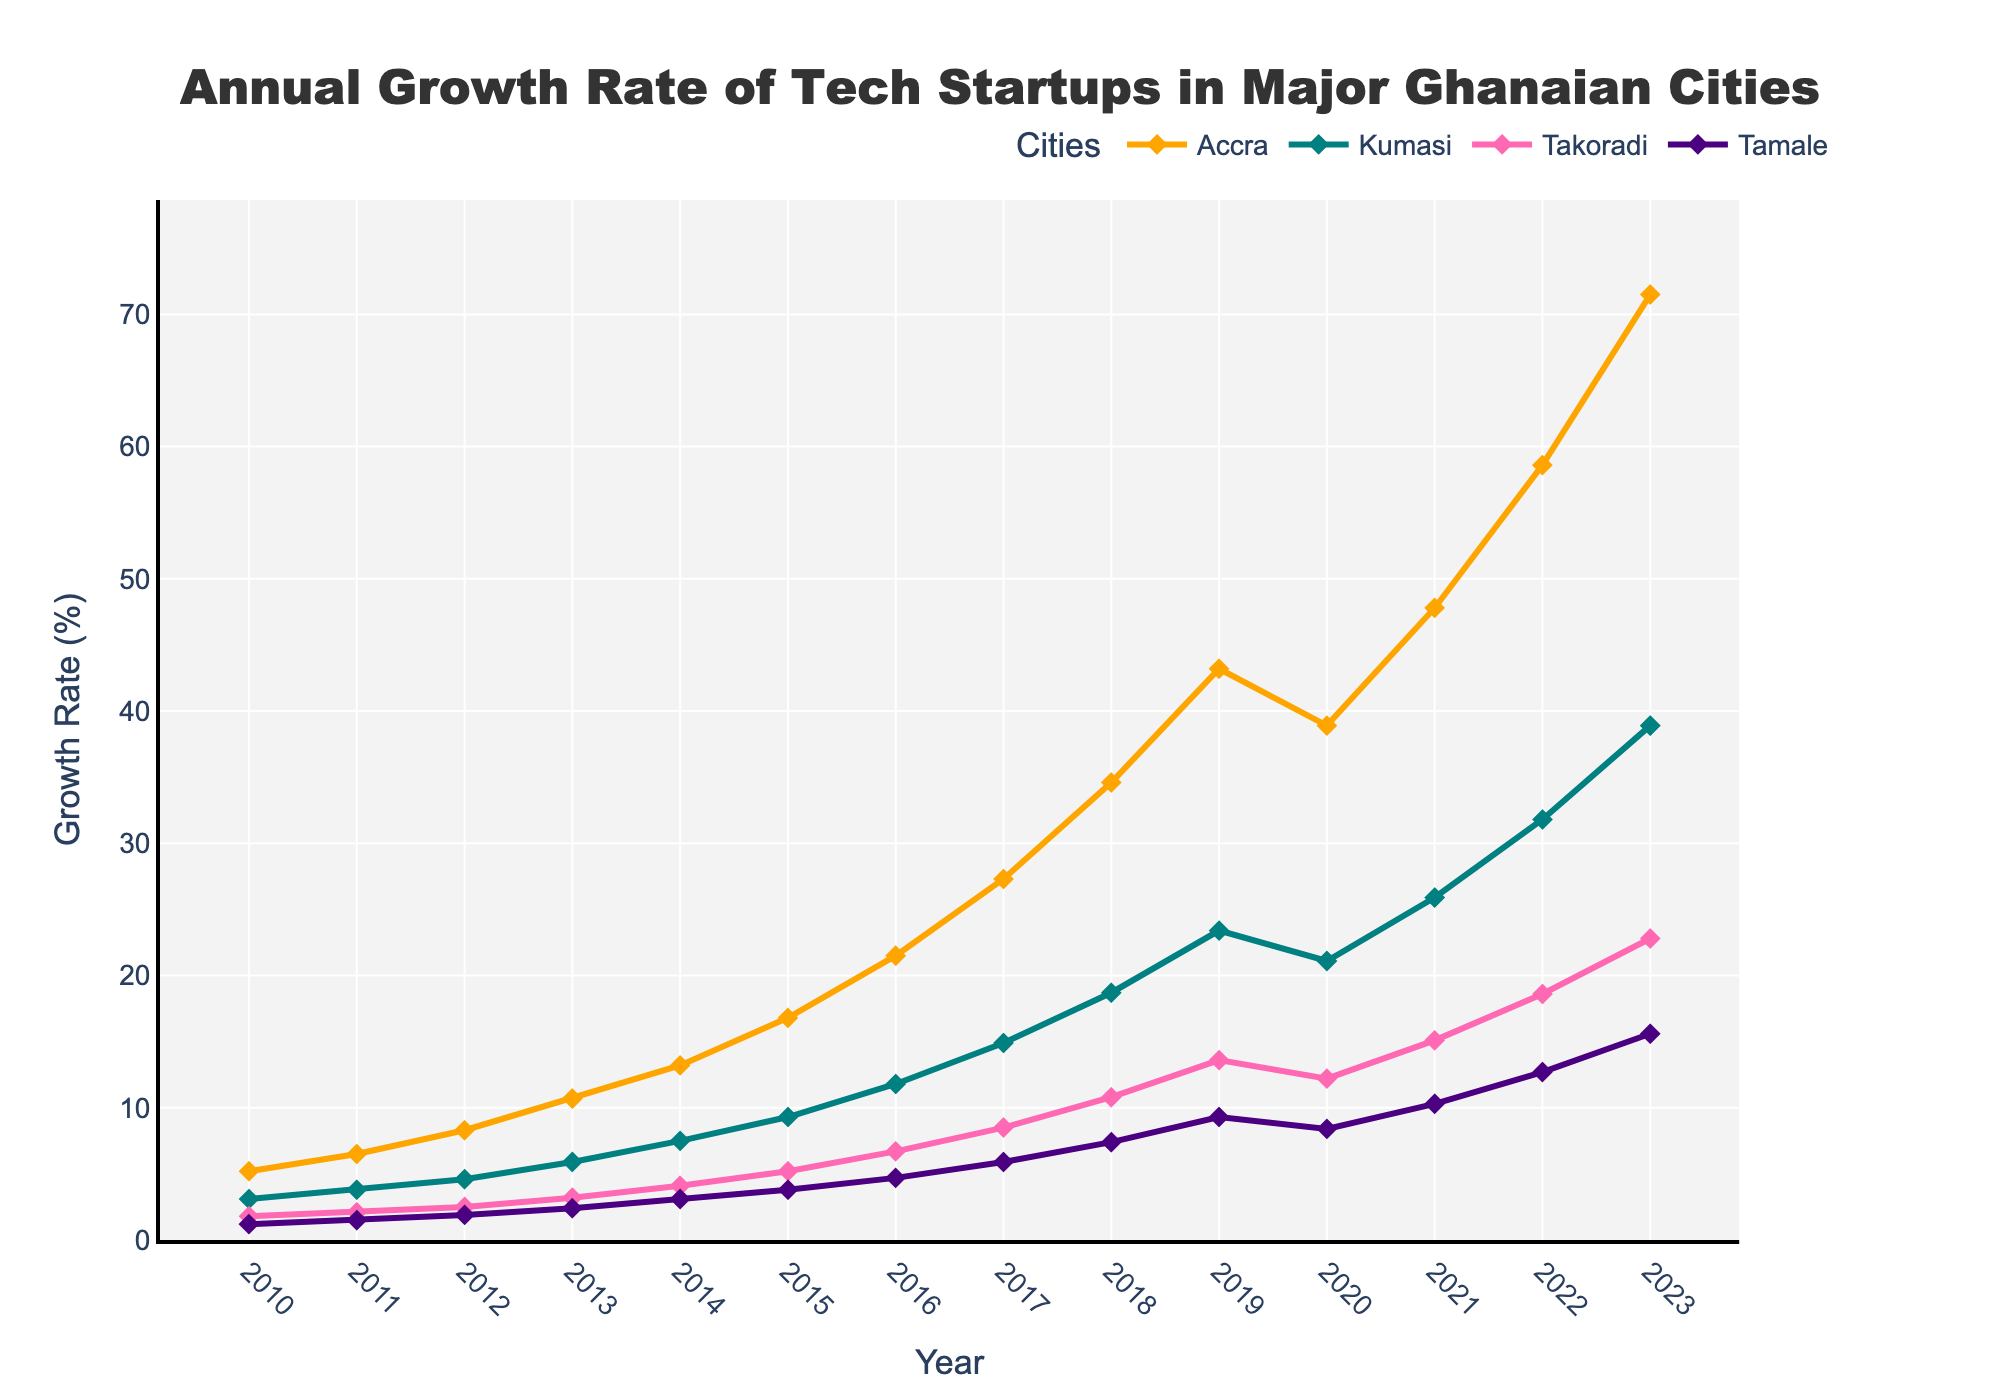What was the growth rate in Accra in 2015 and how does it compare to Kumasi's growth rate the same year? Refer to the plot and find the data points for Accra and Kumasi in the year 2015. Accra has a growth rate of 16.8% and Kumasi has 9.3%. Comparing these, Accra's growth rate is higher.
Answer: Accra had 16.8%, Kumasi had 9.3%, Accra's was higher Which city had the highest growth rate in the year 2023? Locate the year 2023 on the x-axis and observe the highest point among all the lines representing different cities. The line for Accra is the highest.
Answer: Accra How did the growth rate of tech startups in Tamale change from 2010 to 2023? Observe Tamale's growth rate from the year 2010 to 2023. The rate increased from 1.2% in 2010 to 15.6% in 2023.
Answer: Increased from 1.2% to 15.6% Between which consecutive years did Accra experience the most significant increase in growth rate? Look at the line representing Accra and identify the segment with the steepest upward slope. The most significant increase is from 2019 to 2020, where growth went from 43.2% to 38.9%.
Answer: 2019 to 2020 Compare the trends of growth rates in Kumasi and Takoradi from 2010 to 2023. Observe the lines for Kumasi and Takoradi. Kumasi shows a steady and stronger increase over the years compared to Takoradi, with more significant growth acceleration after 2015.
Answer: Kumasi grew faster, especially after 2015 What was the average growth rate of tech startups in Tamale over the period 2010-2023? Calculate the average by summing Tamale's growth rates from 2010 to 2023 and dividing by the number of years. (1.2 + 1.5 + 1.9 + 2.4 + 3.1 + 3.8 + 4.7 + 5.9 + 7.4 + 9.3 + 8.4 + 10.3 + 12.7 + 15.6) / 14 = 6.07
Answer: 6.07 Which city saw a decline in growth rate between any two consecutive years? Check each city's line for any downward slope between consecutive years. Accra shows a decline from 2019 (43.2%) to 2020 (38.9%).
Answer: Accra What is the overall trend observed in tech startup growth rates across all cities from 2010 to 2023? All cities exhibit an overall upward trend with significant growth, despite minor fluctuations like the dip in Accra's growth rate around 2020.
Answer: Upward trending 